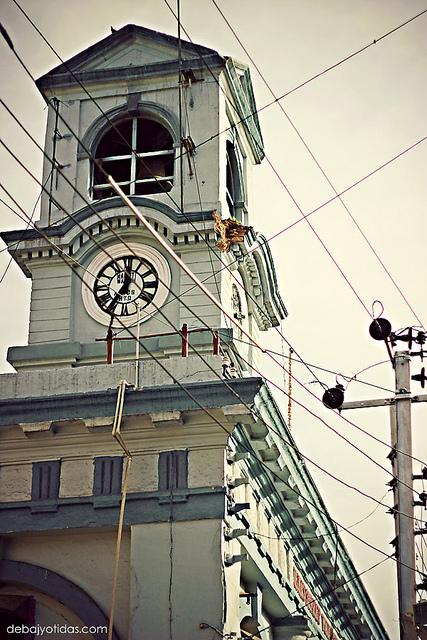What are those lines for?
Concise answer only. Power. What time is it in the photo?
Short answer required. 12:35. Does this building have a clock tower?
Be succinct. Yes. What is covering the building?
Be succinct. Wires. 